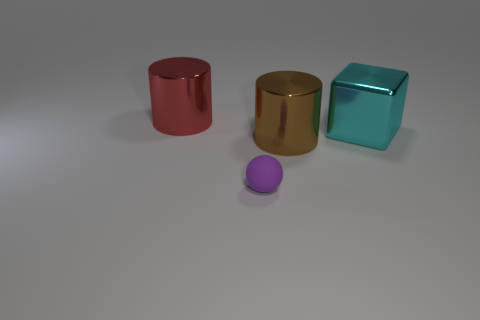There is a large thing left of the tiny purple ball; are there any big red cylinders on the right side of it?
Give a very brief answer. No. There is another large thing that is the same shape as the big brown metallic thing; what color is it?
Give a very brief answer. Red. How many objects are either large things that are to the right of the large red object or red cylinders?
Give a very brief answer. 3. What material is the purple thing that is in front of the big cylinder that is to the left of the shiny cylinder that is to the right of the small rubber object made of?
Provide a succinct answer. Rubber. Is the number of large objects that are in front of the large cube greater than the number of tiny rubber spheres that are behind the brown cylinder?
Give a very brief answer. Yes. What number of spheres are either tiny green metallic objects or tiny rubber objects?
Ensure brevity in your answer.  1. There is a cylinder in front of the big metal object on the right side of the brown thing; how many objects are in front of it?
Offer a terse response. 1. Are there more cyan cubes than shiny cylinders?
Offer a very short reply. No. Do the brown metallic cylinder and the cyan object have the same size?
Your answer should be very brief. Yes. How many objects are either tiny purple rubber spheres or big brown blocks?
Ensure brevity in your answer.  1. 